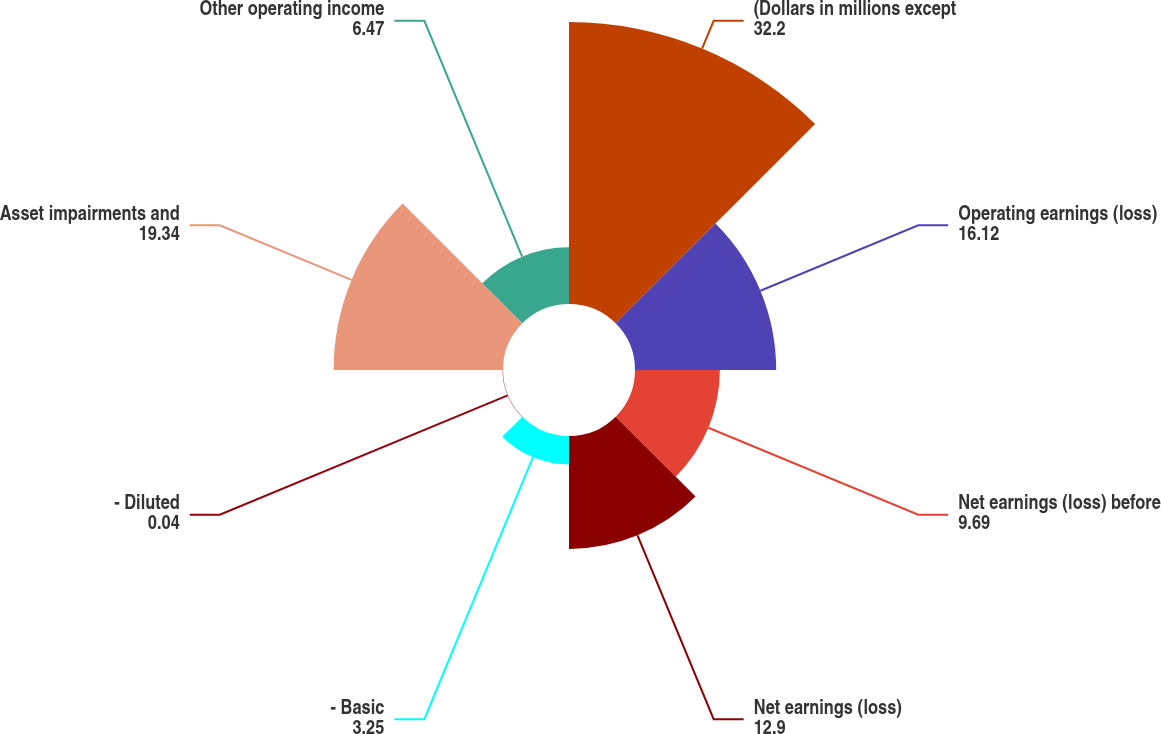<chart> <loc_0><loc_0><loc_500><loc_500><pie_chart><fcel>(Dollars in millions except<fcel>Operating earnings (loss)<fcel>Net earnings (loss) before<fcel>Net earnings (loss)<fcel>- Basic<fcel>- Diluted<fcel>Asset impairments and<fcel>Other operating income<nl><fcel>32.2%<fcel>16.12%<fcel>9.69%<fcel>12.9%<fcel>3.25%<fcel>0.04%<fcel>19.34%<fcel>6.47%<nl></chart> 